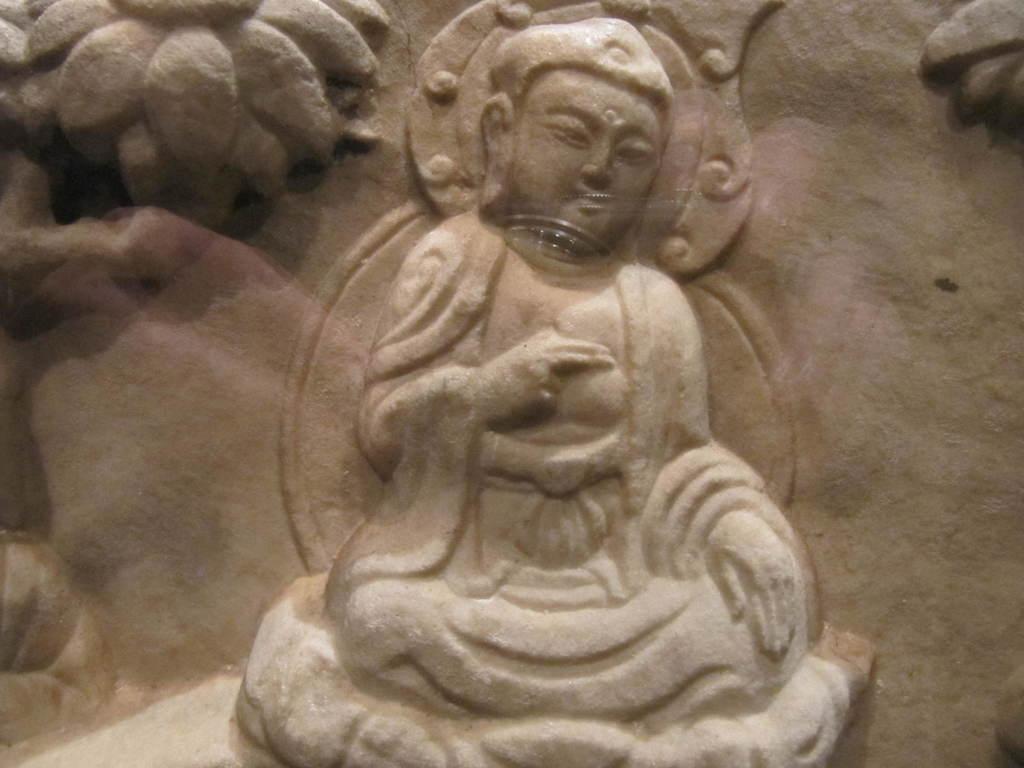In one or two sentences, can you explain what this image depicts? In the middle of this image, there is a sculpture of a person. On the top left, there is a sculpture of a flower. On the top right, there is a sculpture of an object. On the left side, there is a sculpture. 